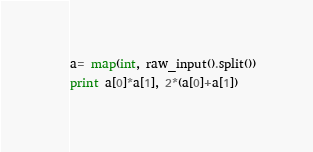Convert code to text. <code><loc_0><loc_0><loc_500><loc_500><_Python_>a= map(int, raw_input().split())
print a[0]*a[1], 2*(a[0]+a[1])</code> 